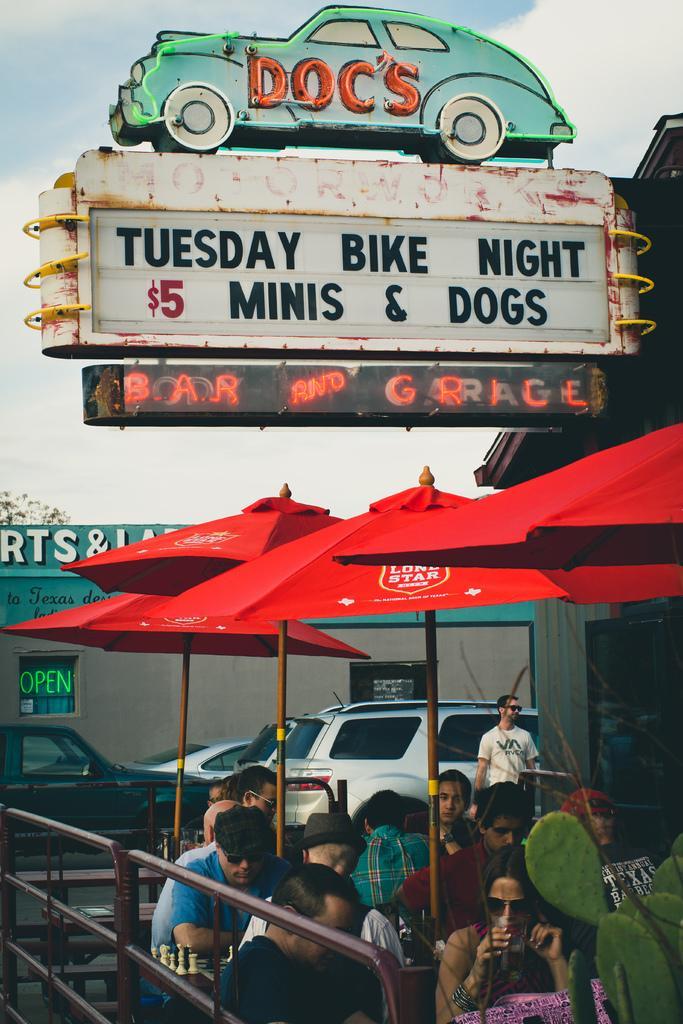Describe this image in one or two sentences. In this picture I can see number of people in front, in which most of them are sitting on chairs and I can see the railings and umbrellas near to them. In the background I can see the buildings, few cars and I see boards on which something is written and I can see the sky on the top of this picture. 